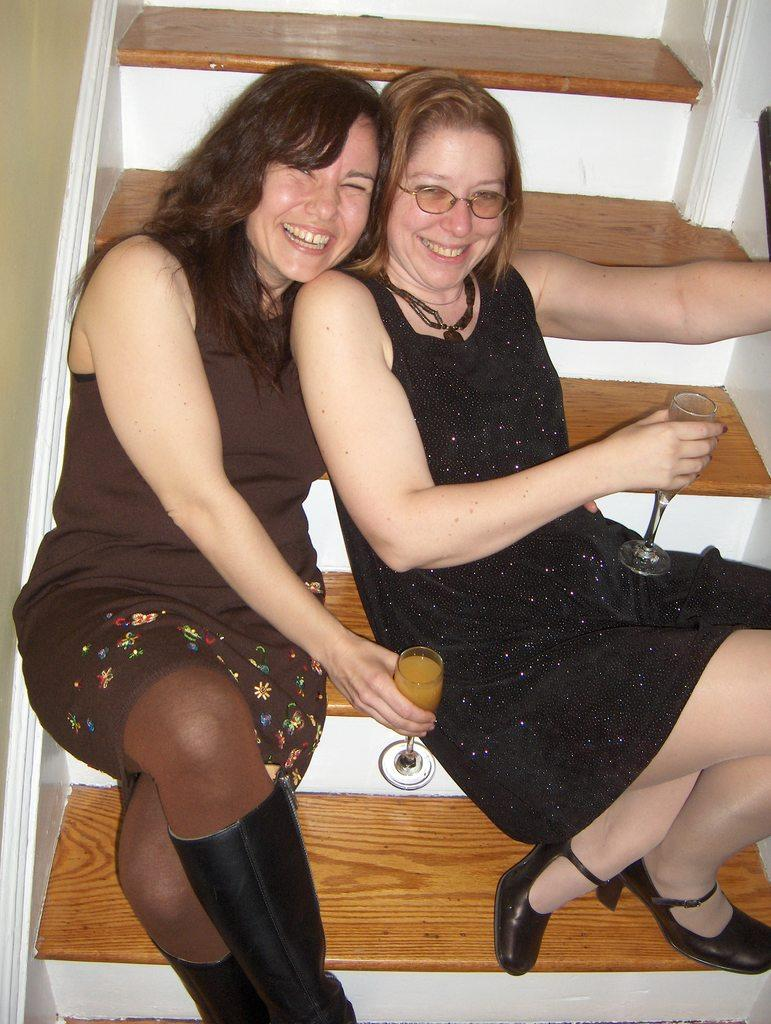How many people are in the image? There are two women in the image. What are the women doing in the image? The women are sitting on stairs. What are the women holding in their hands? The women are holding glasses of some drink. What type of ant can be seen crawling on the stairs in the image? There are no ants present in the image; it only features two women sitting on stairs and holding glasses of some drink. 